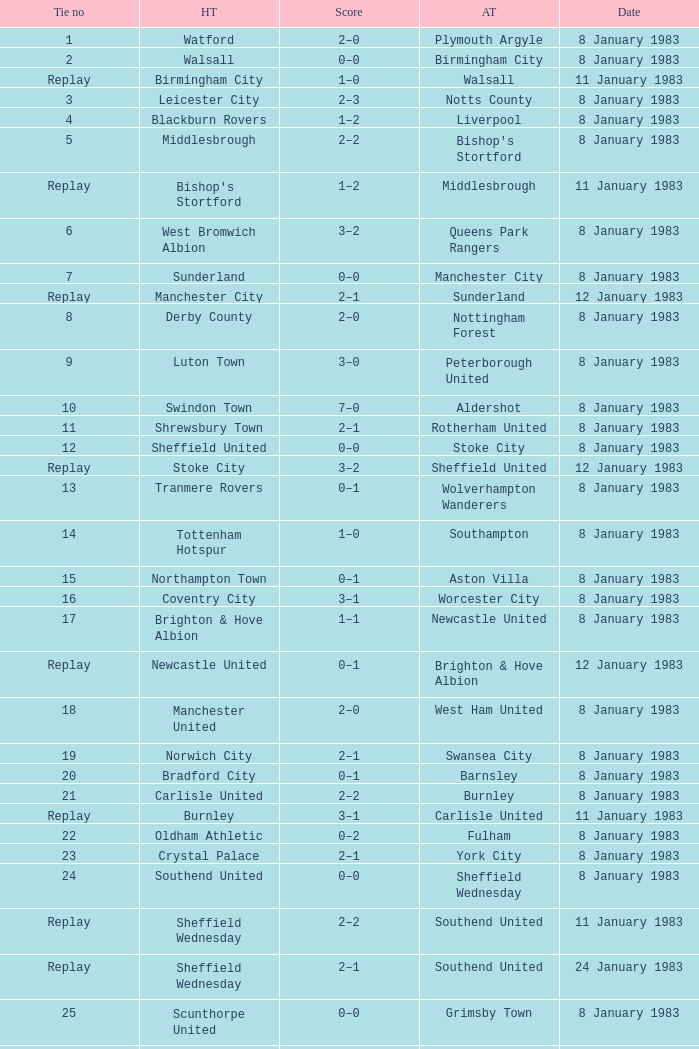On what date was Tie #13 played? 8 January 1983. 